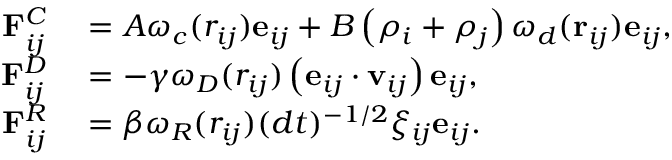<formula> <loc_0><loc_0><loc_500><loc_500>\begin{array} { r l } { F _ { i j } ^ { C } } & = A \omega _ { c } ( r _ { i j } ) e _ { i j } + B \left ( \rho _ { i } + \rho _ { j } \right ) \omega _ { d } ( r _ { i j } ) e _ { i j } , } \\ { F _ { i j } ^ { D } } & = - \gamma \omega _ { D } ( r _ { i j } ) \left ( e _ { i j } \cdot v _ { i j } \right ) e _ { i j } , } \\ { F _ { i j } ^ { R } } & = \beta \omega _ { R } ( r _ { i j } ) ( d t ) ^ { - 1 / 2 } \xi _ { i j } e _ { i j } . } \end{array}</formula> 